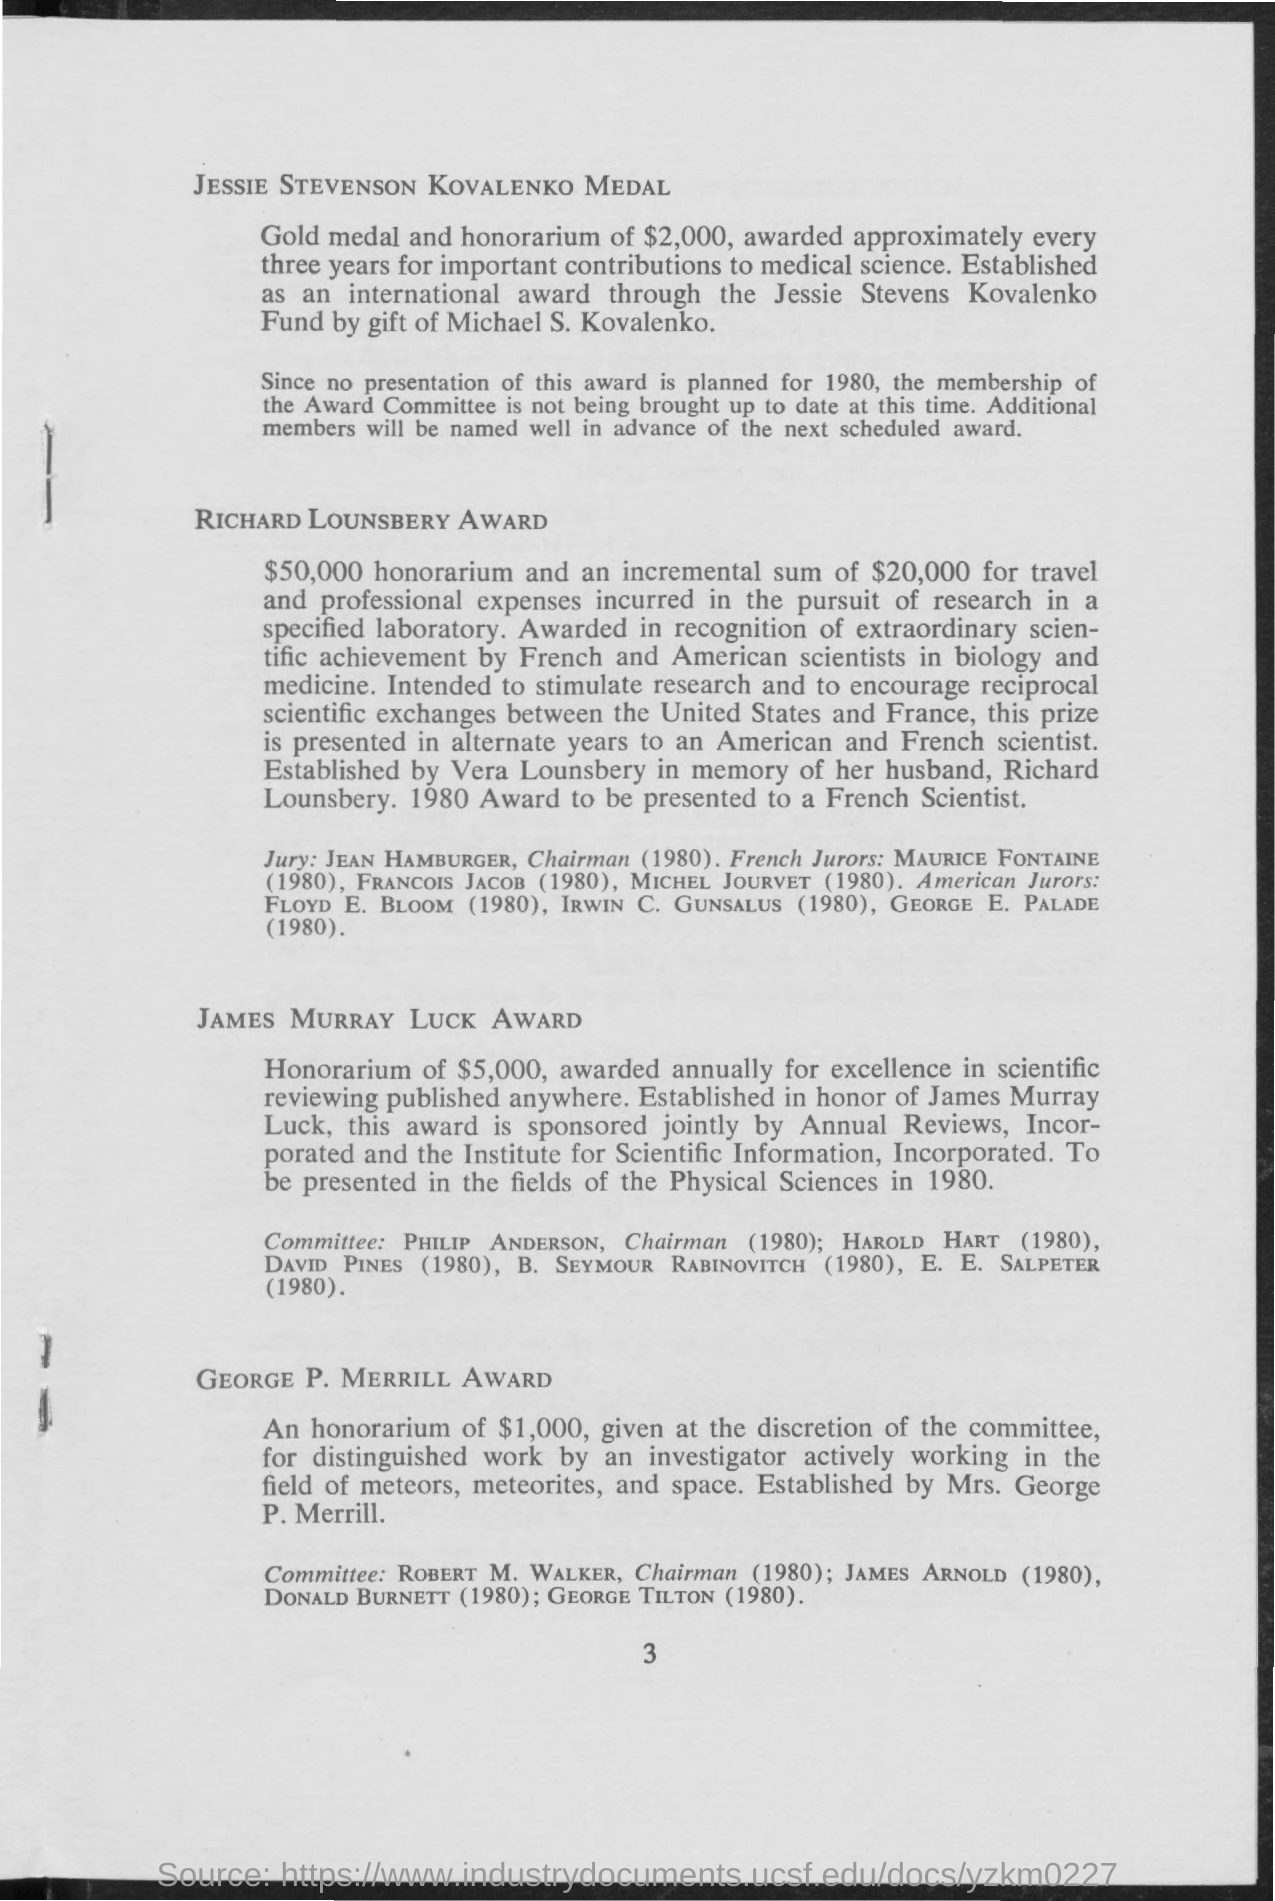List a handful of essential elements in this visual. The Richard Lounsbery Award is an honor that provides a $50,000 honorarium and an additional $20,000 for travel and professional expenses incurred in a specified laboratory. In 1980, the Richard Lounsbery Award was given to a French scientist for their outstanding contributions to the field. The George P. Merrill Award was presented to workers who demonstrated exceptional contributions in the fields of meteoroids, meteorites, and space exploration. In 1980, the Lemurs Murray Luck Award was presented to individuals in the field of physical sciences. The amount given in the George P. Merrill Award is $1,000. 